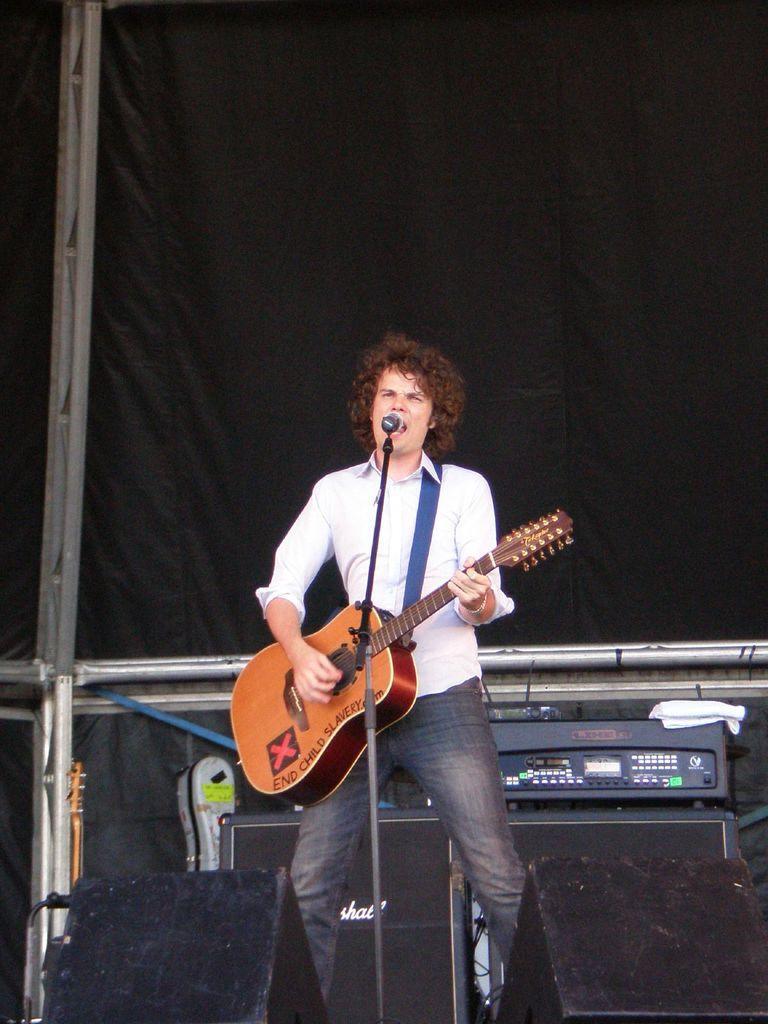In one or two sentences, can you explain what this image depicts? This is a picture of a man holding a guitar and singing a song in front of the man there is a microphone with stand. Background of the man is a music instrument and a black cloth. 